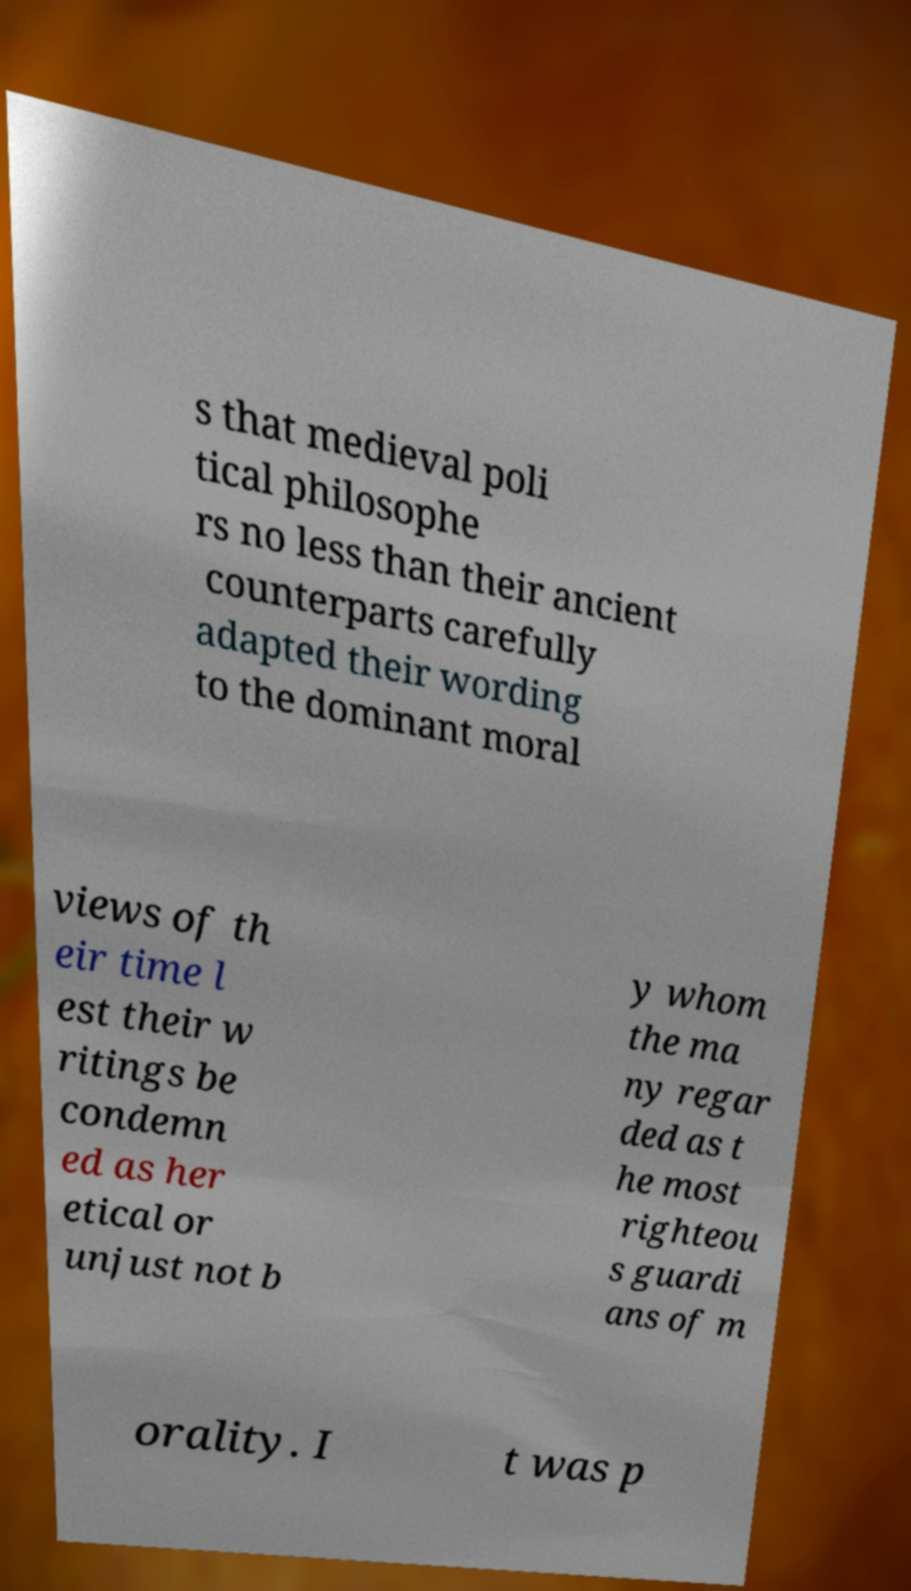Could you extract and type out the text from this image? s that medieval poli tical philosophe rs no less than their ancient counterparts carefully adapted their wording to the dominant moral views of th eir time l est their w ritings be condemn ed as her etical or unjust not b y whom the ma ny regar ded as t he most righteou s guardi ans of m orality. I t was p 